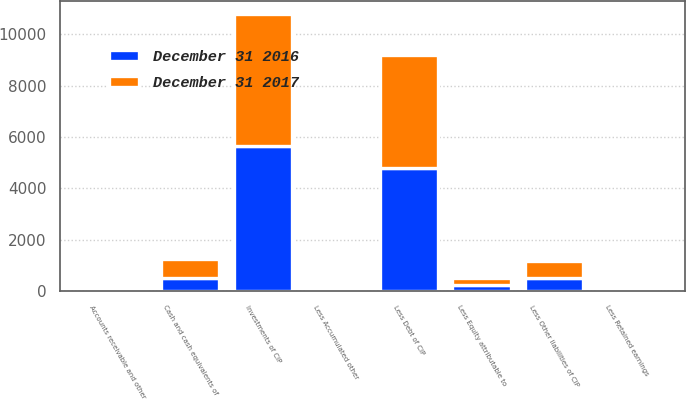<chart> <loc_0><loc_0><loc_500><loc_500><stacked_bar_chart><ecel><fcel>Cash and cash equivalents of<fcel>Accounts receivable and other<fcel>Investments of CIP<fcel>Less Debt of CIP<fcel>Less Other liabilities of CIP<fcel>Less Retained earnings<fcel>Less Accumulated other<fcel>Less Equity attributable to<nl><fcel>December 31 2016<fcel>511.3<fcel>131.5<fcel>5658<fcel>4799.8<fcel>498.8<fcel>16.7<fcel>16.6<fcel>243.2<nl><fcel>December 31 2017<fcel>742.2<fcel>106.2<fcel>5116.1<fcel>4403.1<fcel>673.4<fcel>19<fcel>18<fcel>283.7<nl></chart> 